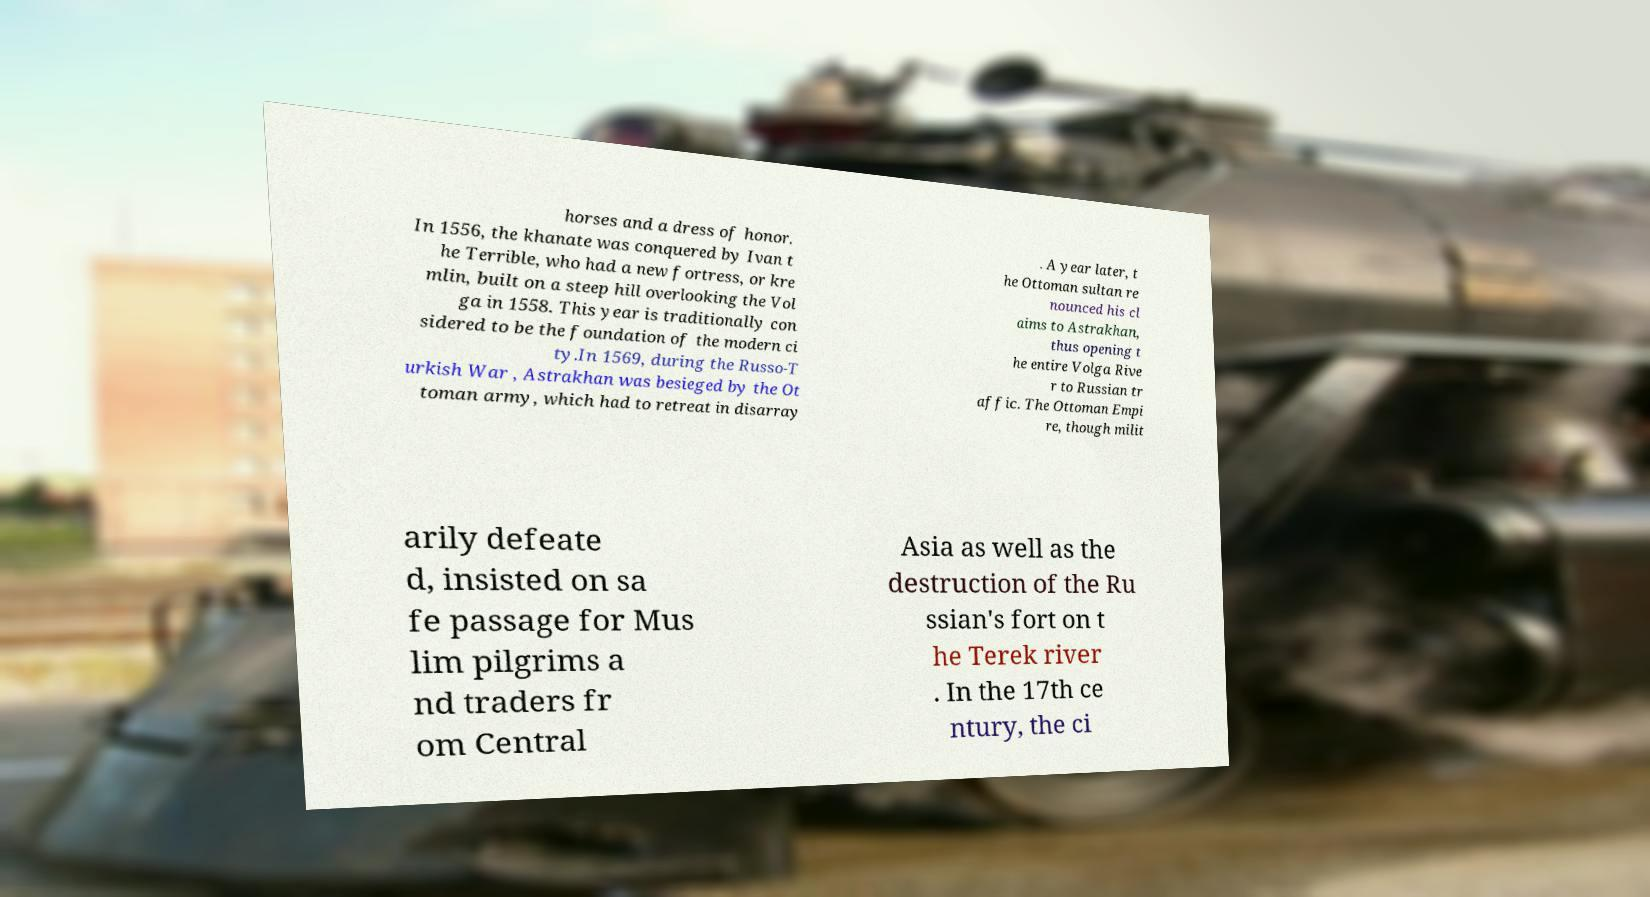Can you read and provide the text displayed in the image?This photo seems to have some interesting text. Can you extract and type it out for me? horses and a dress of honor. In 1556, the khanate was conquered by Ivan t he Terrible, who had a new fortress, or kre mlin, built on a steep hill overlooking the Vol ga in 1558. This year is traditionally con sidered to be the foundation of the modern ci ty.In 1569, during the Russo-T urkish War , Astrakhan was besieged by the Ot toman army, which had to retreat in disarray . A year later, t he Ottoman sultan re nounced his cl aims to Astrakhan, thus opening t he entire Volga Rive r to Russian tr affic. The Ottoman Empi re, though milit arily defeate d, insisted on sa fe passage for Mus lim pilgrims a nd traders fr om Central Asia as well as the destruction of the Ru ssian's fort on t he Terek river . In the 17th ce ntury, the ci 